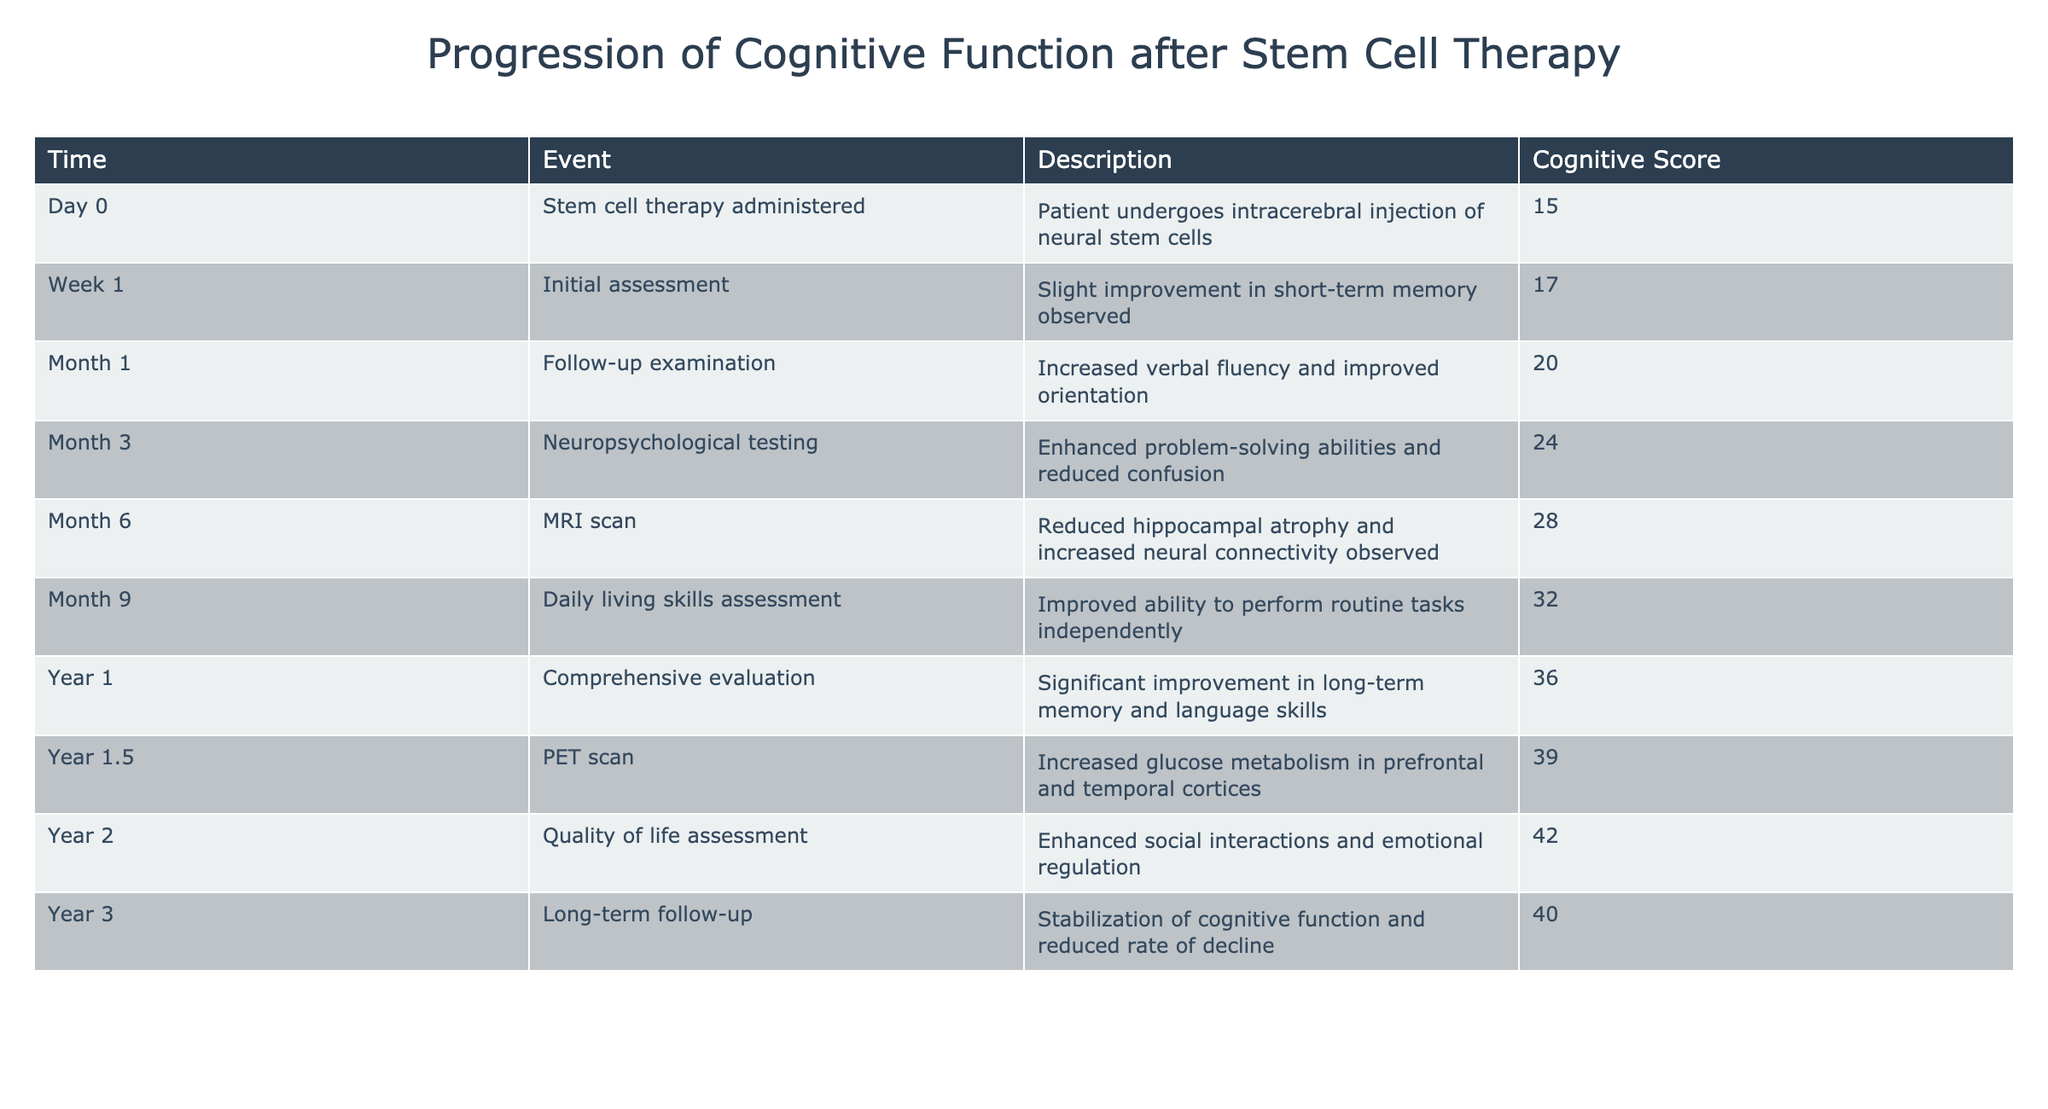What was the cognitive score on Day 0? The table lists the cognitive score on Day 0 as 15.
Answer: 15 What improvement was noted in the first month? The description for Month 1 states that there was increased verbal fluency and improved orientation observed, suggesting cognitive improvements.
Answer: Increased verbal fluency and improved orientation Was there a significant change in cognitive function by Year 1? The description for Year 1 indicates a significant improvement in long-term memory and language skills, which confirms a notable change in cognitive function.
Answer: Yes What is the cognitive score at Year 1.5? The table records the cognitive score at Year 1.5 as 39.
Answer: 39 How many days passed from the initial assessment to the MRI scan? The initial assessment took place at Week 1 (7 days) and the MRI scan was done at Month 6 (approximately 180 days), so the time from the initial assessment to the MRI scan is 180 - 7 = 173 days.
Answer: 173 days What was the average cognitive score for the first year? To find the average from Day 0 to Year 1, we sum the cognitive scores: (15 + 17 + 20 + 24 + 28 + 32 + 36) = 172. There are 7 scores, so the average is 172/7 = approximately 24.57.
Answer: Approximately 24.57 Did the cognitive score decline by Year 3 compared to Year 2? The cognitive score at Year 2 is 42 and at Year 3 it is 40. Since 40 is less than 42, this indicates a decline in cognitive score.
Answer: Yes What two areas of cognitive function improved by Year 2? The description for Year 2 highlights enhanced social interactions and emotional regulation as areas of improvement.
Answer: Enhanced social interactions and emotional regulation Which event showed the highest cognitive score and what was it? The cognitive score reached its highest point of 42 at Year 2, during the quality of life assessment.
Answer: Year 2, score of 42 